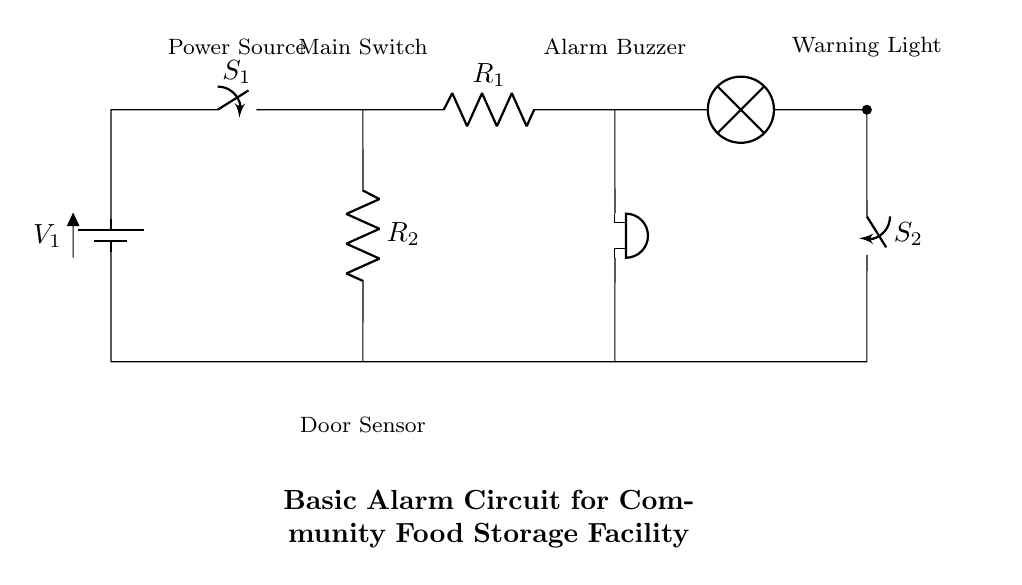What is the main power source in the circuit? The main power source is labeled as V1, which indicates it is a battery providing voltage to the circuit.
Answer: V1 What does the switch S1 control? Switch S1, labeled as the main switch, indicates that it controls the flow of current in the circuit, enabling or disabling the entire circuit operation.
Answer: Current flow What is the purpose of R1 in this circuit? Resistor R1 is used to limit the current that passes through the buzzer, preventing it from drawing too much current and potentially damaging the component.
Answer: Current limiting How many resistors are in this circuit? The circuit shows two resistors, labeled R1 and R2, which each serve specific functions in the circuit operation regarding current management.
Answer: Two What happens when the door sensor is activated? When the door sensor is activated, it completes the circuit, which initiates the buzzer and may turn on the warning light to signal a security breach.
Answer: Alarm activates Which component indicates a warning visually? The lamp in the circuit diagram serves as the visual warning component, lighting up when the circuit detects a problem, such as when the door sensor is activated.
Answer: Lamp 